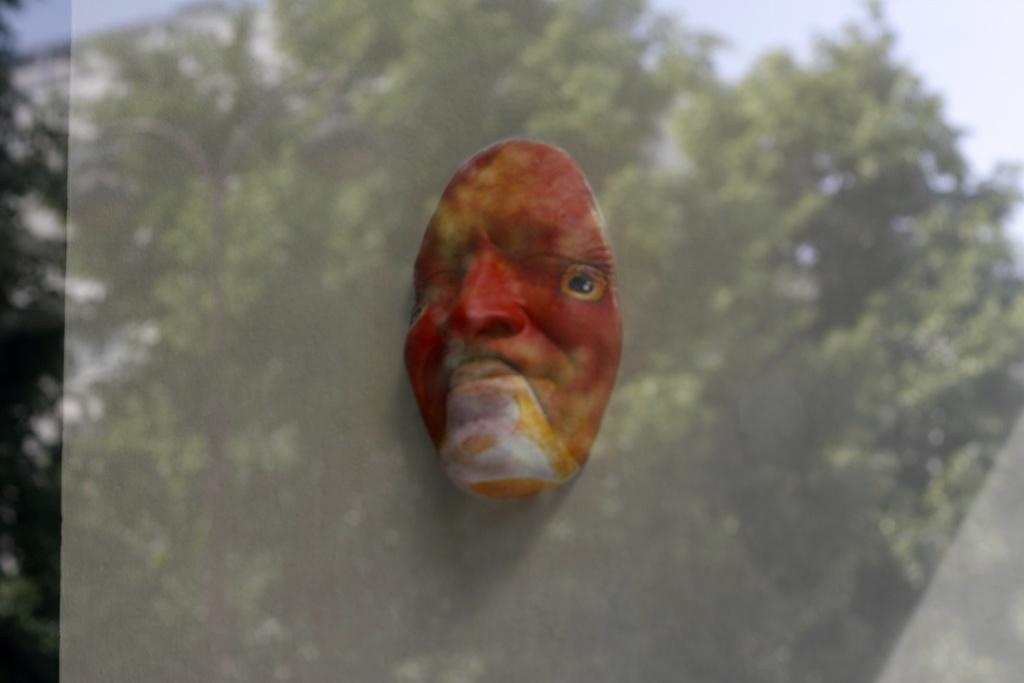What type of mask is shown in the image? There is a red face mask in the image. What other object is present in the image? There is a glass in the image. What can be seen in the reflection of the glass? The reflection of trees is visible in the glass. How many dogs are visible in the image? There are no dogs present in the image. What type of trousers is the person wearing in the image? There is no person visible in the image, so it is impossible to determine what type of trousers they might be wearing. 